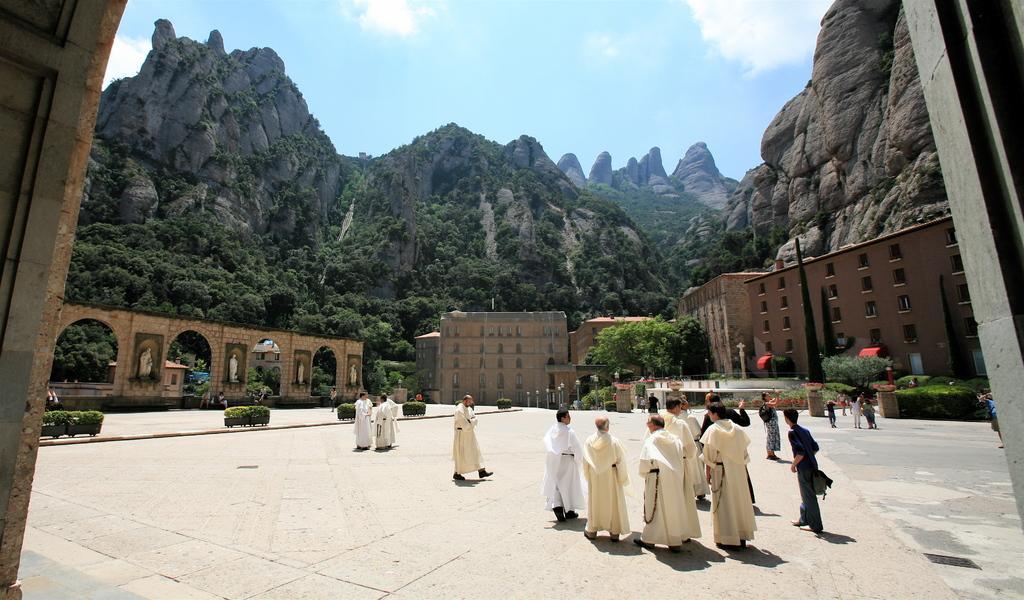How would you summarize this image in a sentence or two? In the foreground of this picture, there are persons on the ground. In the background, there are trees, buildings, sculpture, plants, poles, mountains, sky and the cloud. 